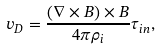Convert formula to latex. <formula><loc_0><loc_0><loc_500><loc_500>v _ { D } = \frac { \left ( \nabla \times B \right ) \times B } { 4 \pi \rho _ { i } } \tau _ { i n } ,</formula> 